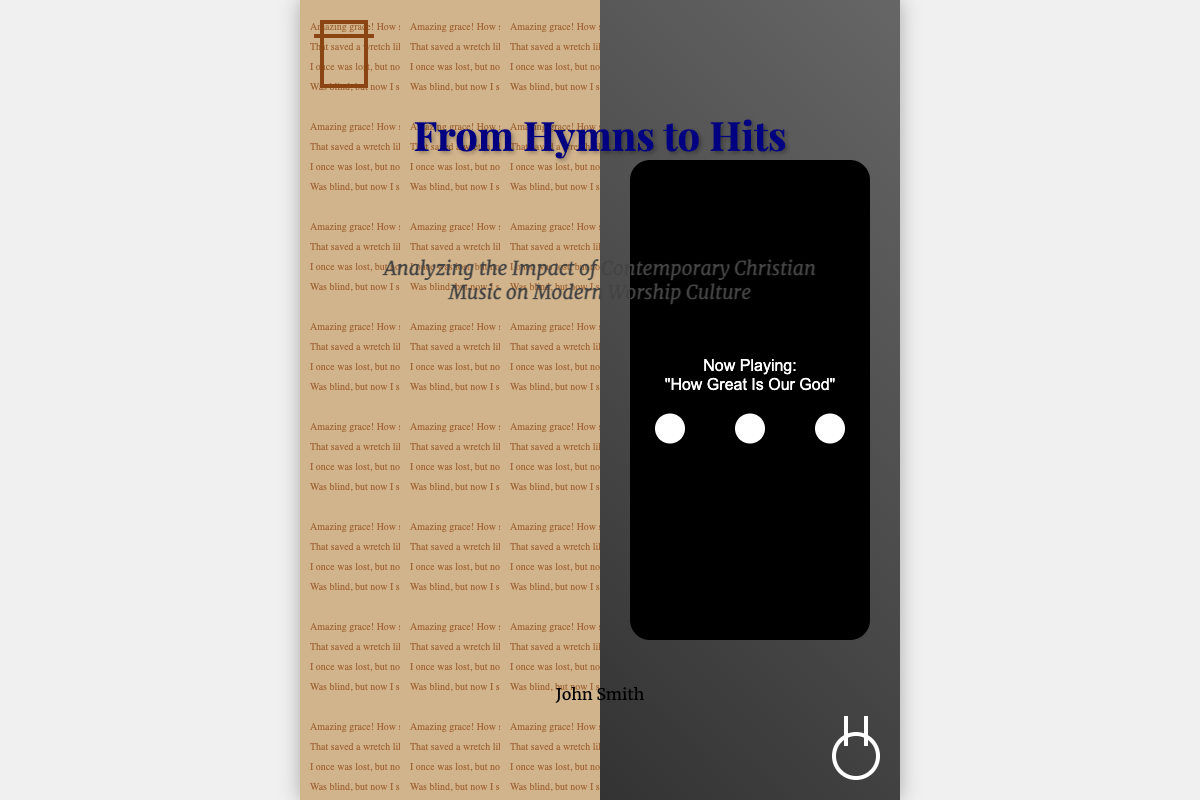What is the title of the book? The title is prominently displayed at the top of the book cover.
Answer: From Hymns to Hits Who is the author of the book? The author's name is located at the bottom of the book cover.
Answer: John Smith What is the subtitle of the book? The subtitle is shown beneath the title, providing more detail about the book's focus.
Answer: Analyzing the Impact of Contemporary Christian Music on Modern Worship Culture What song is currently playing in the digital music player? The song playing is indicated within the player screen element of the cover.
Answer: How Great Is Our God What color is the background of the hymn book section? The background color of the hymn book section is a specific shade that represents traditional hymnal music.
Answer: Tan What visual element symbolizes the transition from traditional to contemporary music? The split design featuring two different music formats represents this transformation.
Answer: Ancient hymn book morphing into a digital music player What shape is the cross in the design? The cross is a traditional symbol of Christianity represented visually in a specific geometric form.
Answer: Rectangular What is the style of the title font? The title font is a specific style that conveys elegance and importance.
Answer: Playfair Display 